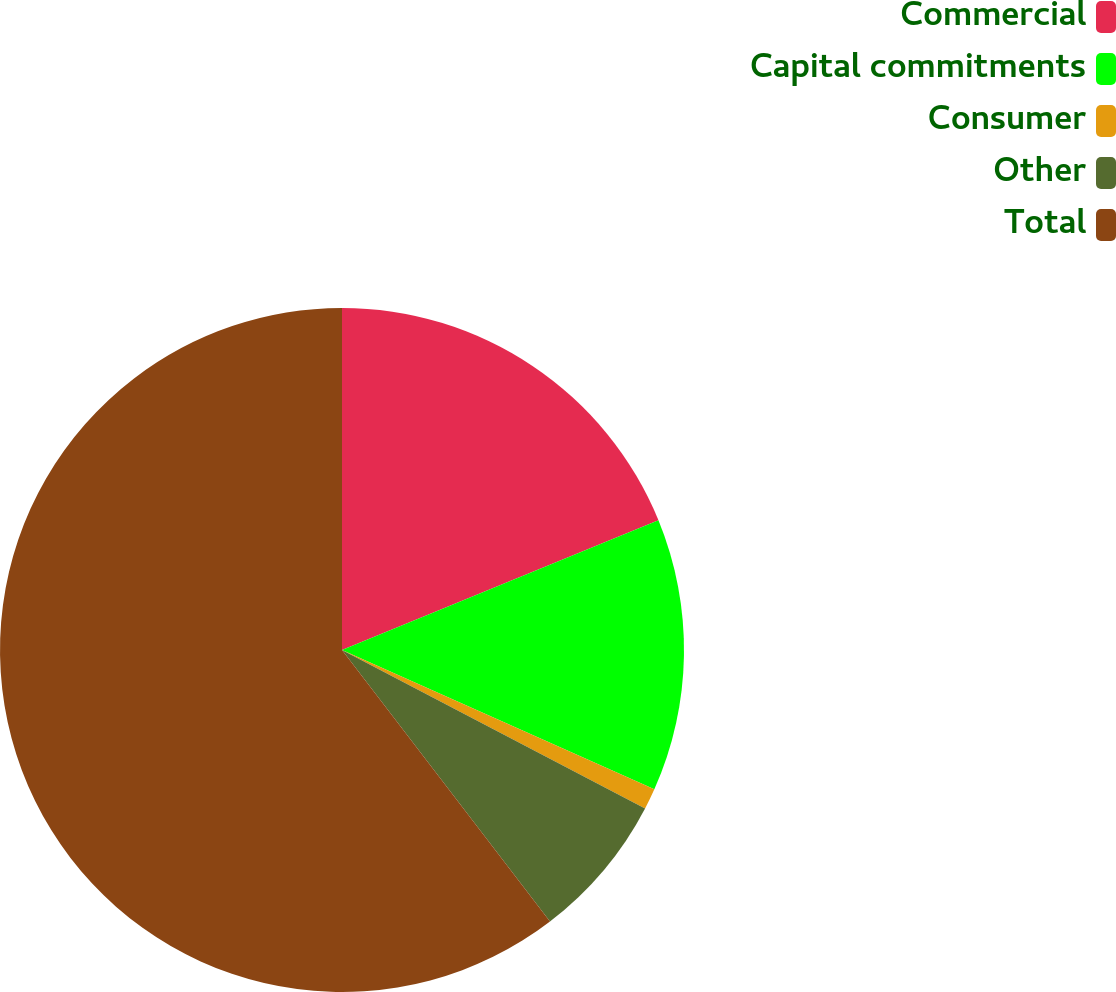<chart> <loc_0><loc_0><loc_500><loc_500><pie_chart><fcel>Commercial<fcel>Capital commitments<fcel>Consumer<fcel>Other<fcel>Total<nl><fcel>18.81%<fcel>12.87%<fcel>0.99%<fcel>6.93%<fcel>60.41%<nl></chart> 